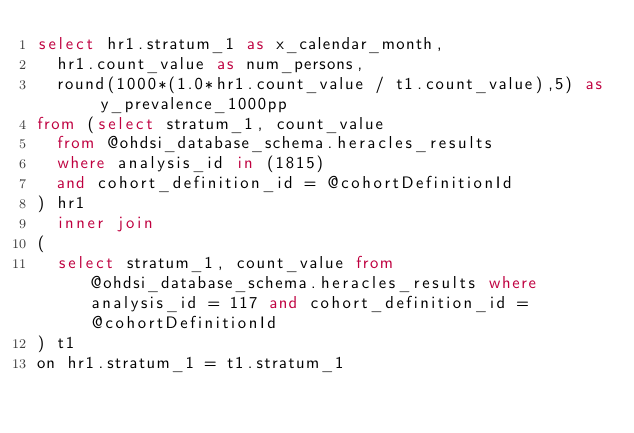Convert code to text. <code><loc_0><loc_0><loc_500><loc_500><_SQL_>select hr1.stratum_1 as x_calendar_month,
	hr1.count_value as num_persons,
	round(1000*(1.0*hr1.count_value / t1.count_value),5) as y_prevalence_1000pp
from (select stratum_1, count_value 
	from @ohdsi_database_schema.heracles_results
	where analysis_id in (1815)
	and cohort_definition_id = @cohortDefinitionId
) hr1
	inner join 
(
	select stratum_1, count_value from @ohdsi_database_schema.heracles_results where analysis_id = 117 and cohort_definition_id = @cohortDefinitionId
) t1
on hr1.stratum_1 = t1.stratum_1</code> 